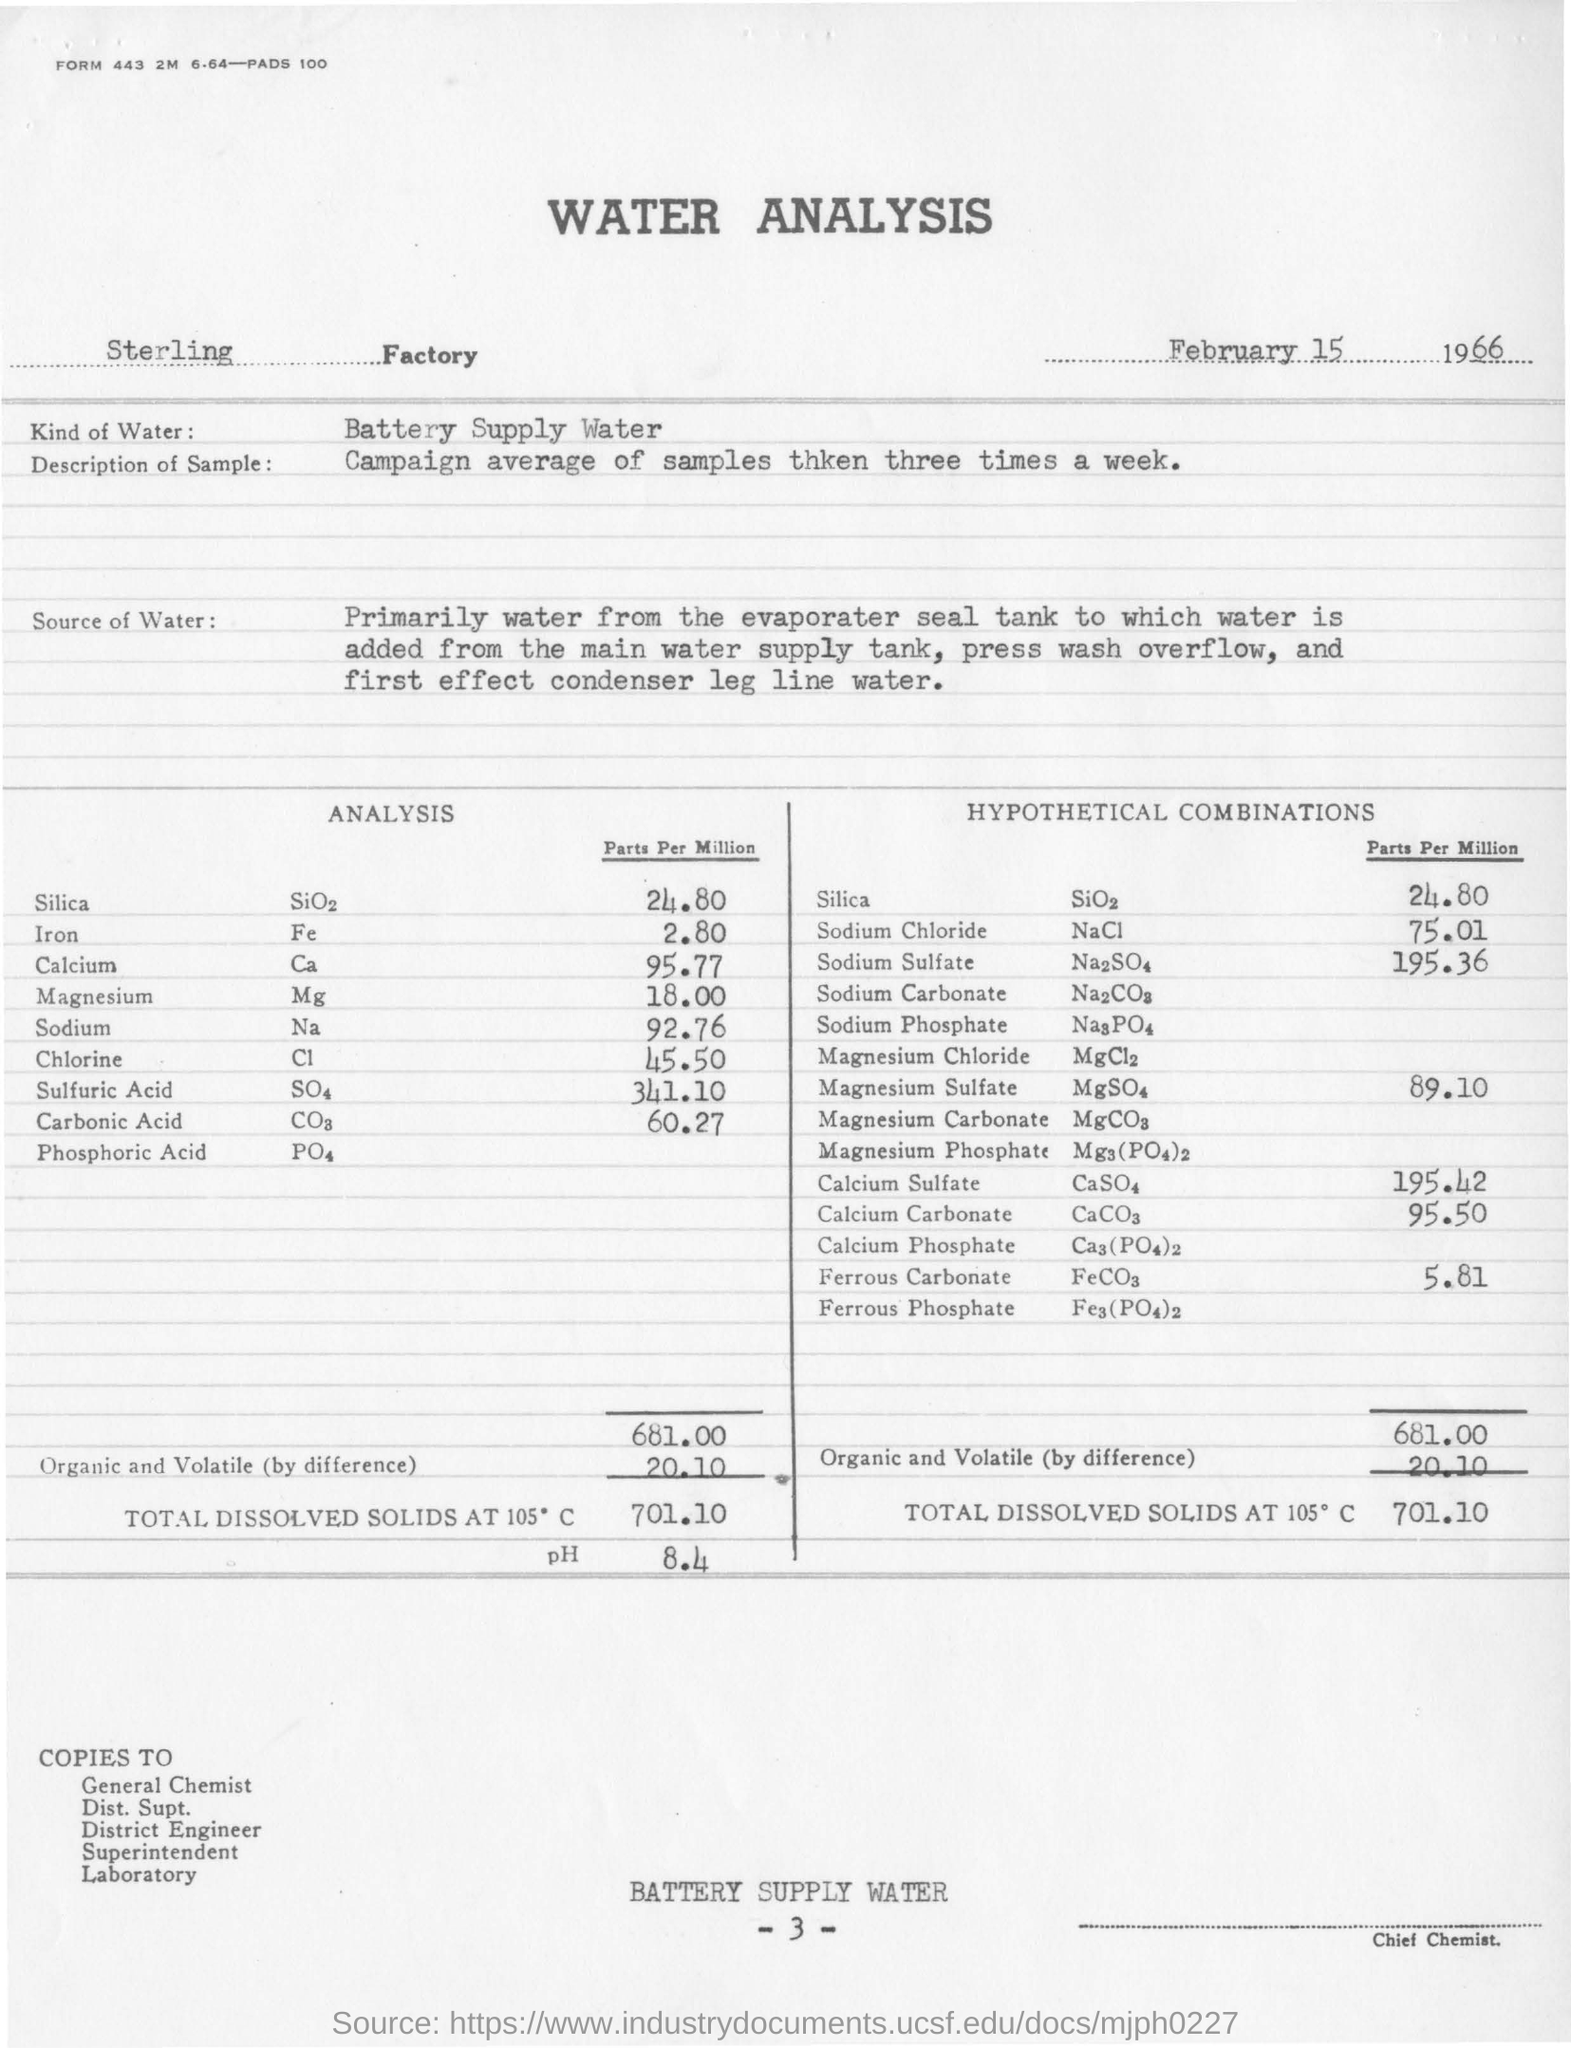Mention a couple of crucial points in this snapshot. Iron is known by its chemical name, Fe. The water analysis should have been signed by the chief chemist, The water being supplied is of a battery type. The title of this document is Water Analysis. The level of silica is 24.80 parts per million. 